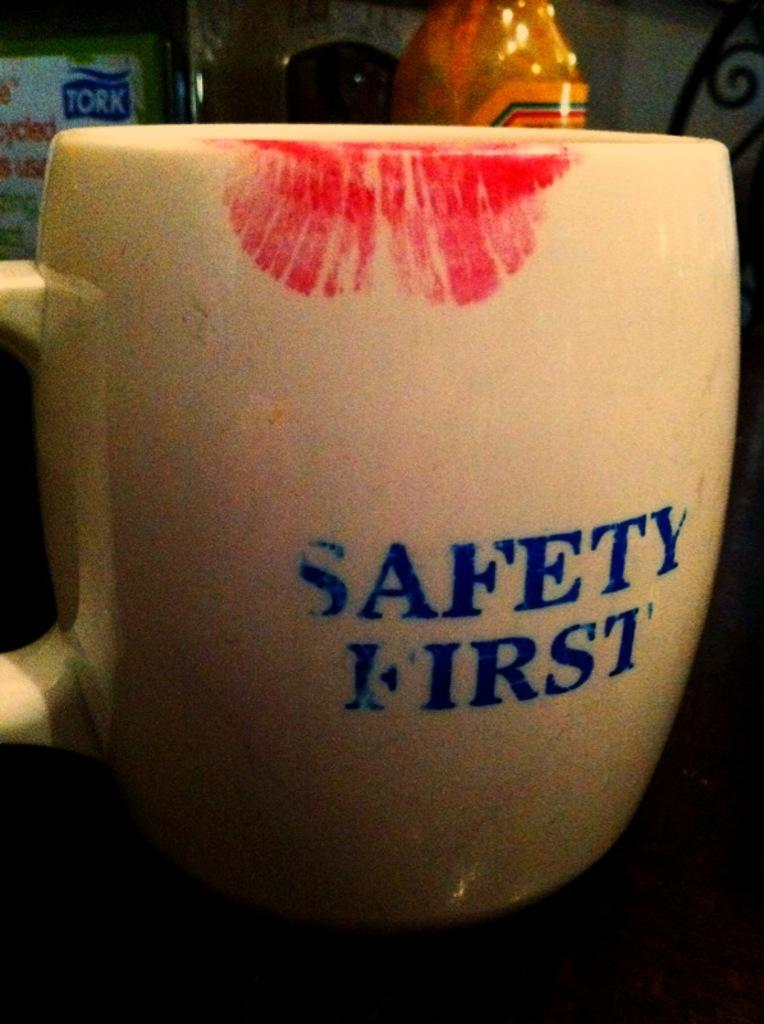<image>
Summarize the visual content of the image. A mug with a lip stain that says Safety First 